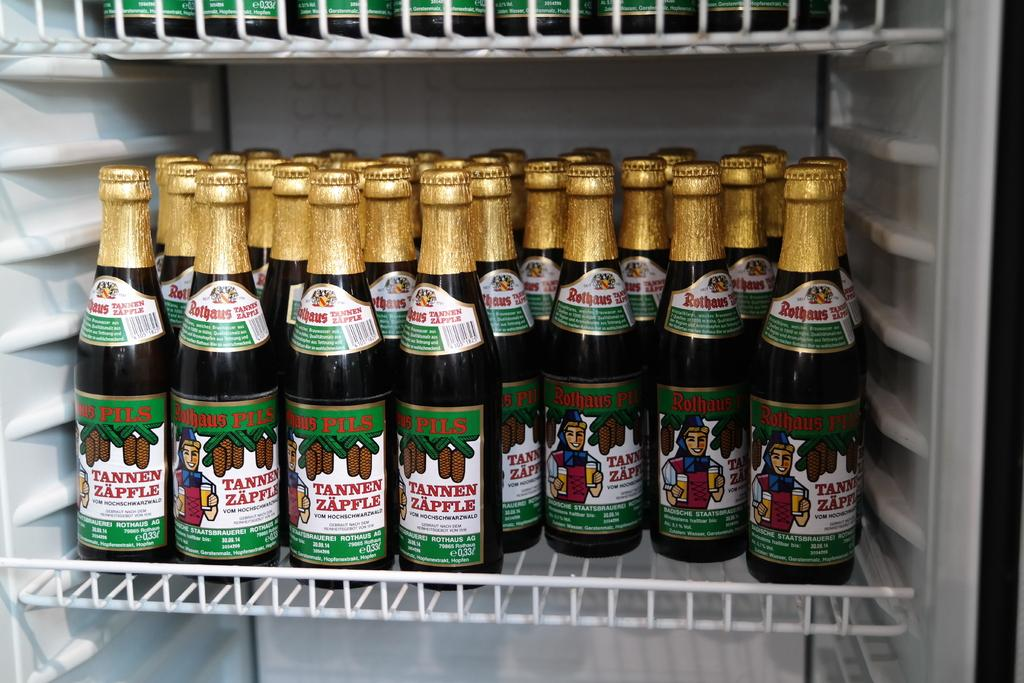Provide a one-sentence caption for the provided image. Bottles of Tannen Zapfle are on the shelf in a refrigerator. 